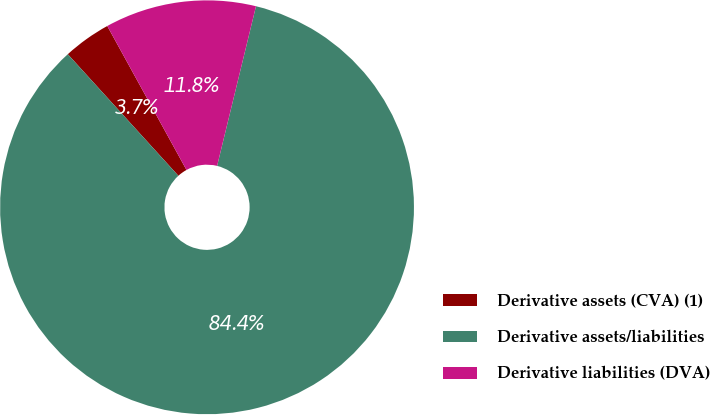Convert chart. <chart><loc_0><loc_0><loc_500><loc_500><pie_chart><fcel>Derivative assets (CVA) (1)<fcel>Derivative assets/liabilities<fcel>Derivative liabilities (DVA)<nl><fcel>3.74%<fcel>84.45%<fcel>11.81%<nl></chart> 